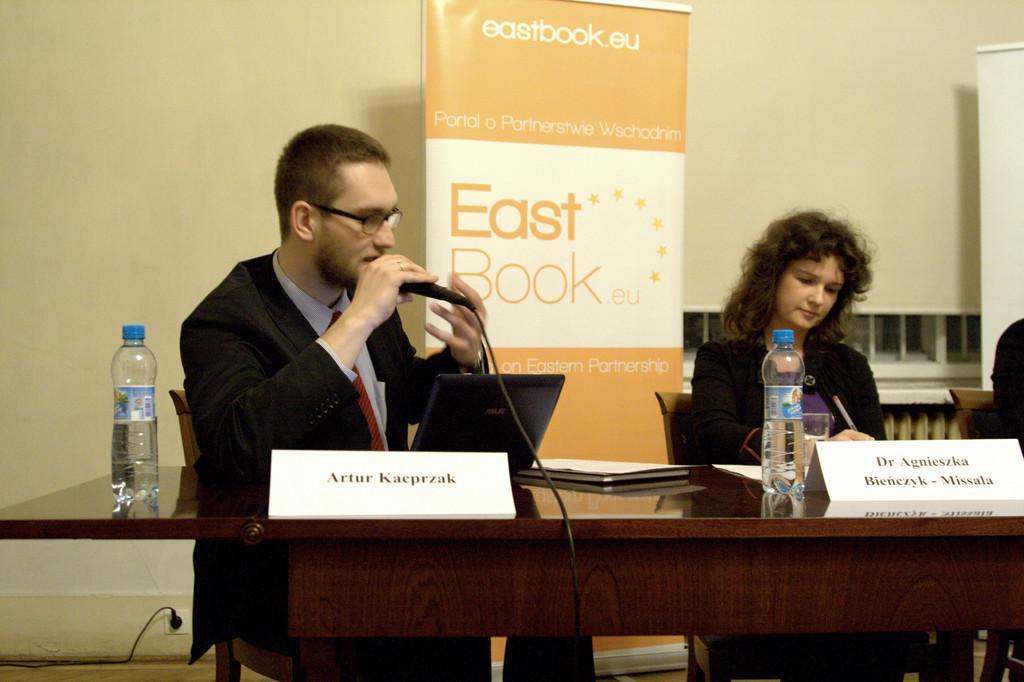Could you give a brief overview of what you see in this image? Here we can see a man and a woman sitting on the chairs. He is talking on the mike and he has spectacles. This is a table. On the table there are bottles, book, papers, laptop, and a glass. In the background we can see banners and wall. 